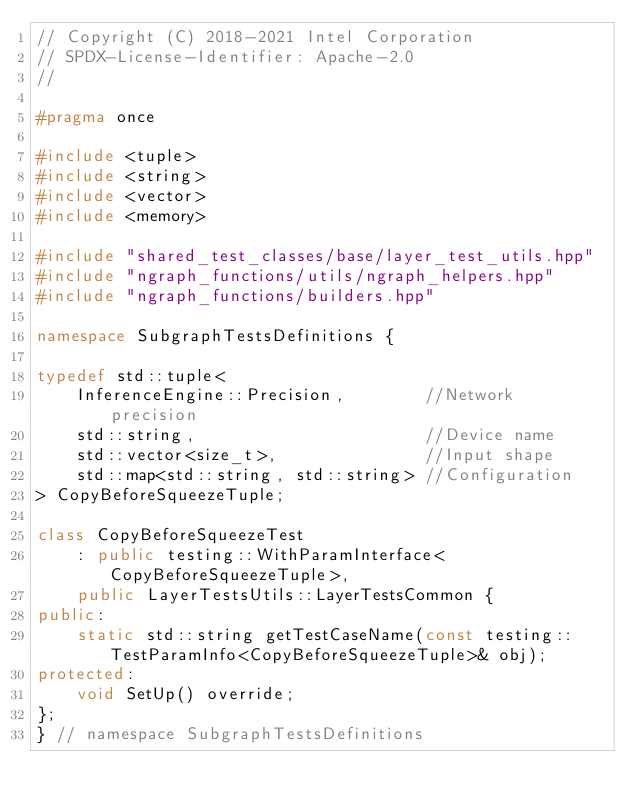Convert code to text. <code><loc_0><loc_0><loc_500><loc_500><_C++_>// Copyright (C) 2018-2021 Intel Corporation
// SPDX-License-Identifier: Apache-2.0
//

#pragma once

#include <tuple>
#include <string>
#include <vector>
#include <memory>

#include "shared_test_classes/base/layer_test_utils.hpp"
#include "ngraph_functions/utils/ngraph_helpers.hpp"
#include "ngraph_functions/builders.hpp"

namespace SubgraphTestsDefinitions {

typedef std::tuple<
    InferenceEngine::Precision,        //Network precision
    std::string,                       //Device name
    std::vector<size_t>,               //Input shape
    std::map<std::string, std::string> //Configuration
> CopyBeforeSqueezeTuple;

class CopyBeforeSqueezeTest
    : public testing::WithParamInterface<CopyBeforeSqueezeTuple>,
    public LayerTestsUtils::LayerTestsCommon {
public:
    static std::string getTestCaseName(const testing::TestParamInfo<CopyBeforeSqueezeTuple>& obj);
protected:
    void SetUp() override;
};
} // namespace SubgraphTestsDefinitions
</code> 